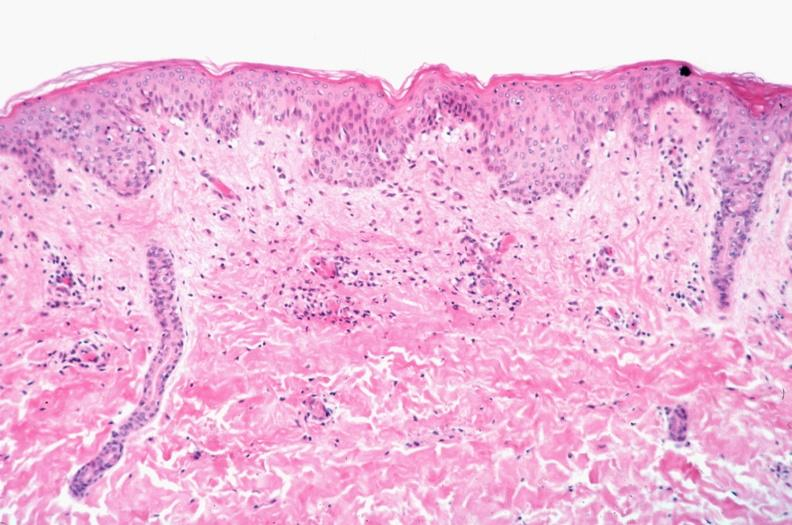what does this image show?
Answer the question using a single word or phrase. Skin 